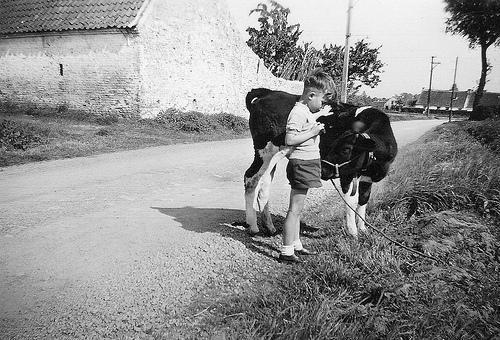How many cows are in the photo?
Give a very brief answer. 1. 